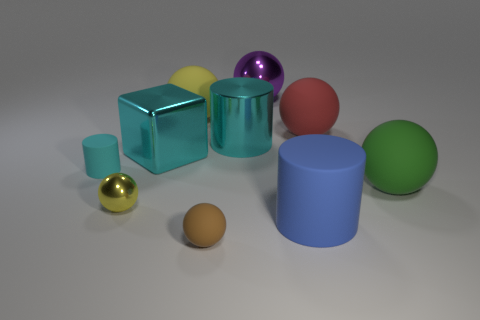Subtract all large shiny balls. How many balls are left? 5 Subtract all purple cylinders. How many yellow spheres are left? 2 Subtract all cyan cylinders. How many cylinders are left? 1 Subtract all balls. How many objects are left? 4 Subtract all large blue cylinders. Subtract all green rubber objects. How many objects are left? 8 Add 6 large blue matte cylinders. How many large blue matte cylinders are left? 7 Add 6 big blue cubes. How many big blue cubes exist? 6 Subtract 0 gray blocks. How many objects are left? 10 Subtract all yellow cubes. Subtract all blue spheres. How many cubes are left? 1 